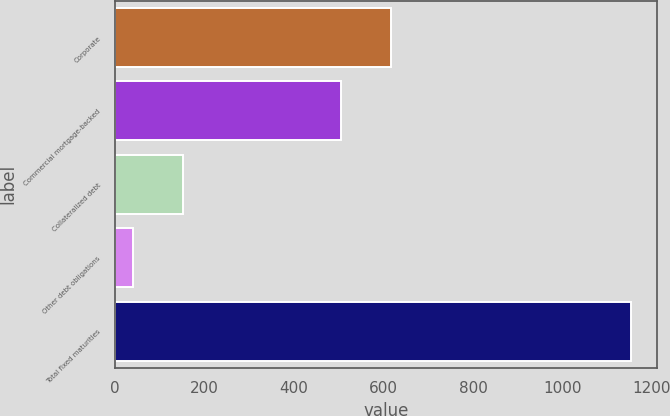Convert chart to OTSL. <chart><loc_0><loc_0><loc_500><loc_500><bar_chart><fcel>Corporate<fcel>Commercial mortgage-backed<fcel>Collateralized debt<fcel>Other debt obligations<fcel>Total fixed maturities<nl><fcel>617.53<fcel>506.1<fcel>151.43<fcel>40<fcel>1154.3<nl></chart> 